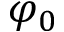Convert formula to latex. <formula><loc_0><loc_0><loc_500><loc_500>\varphi _ { 0 }</formula> 